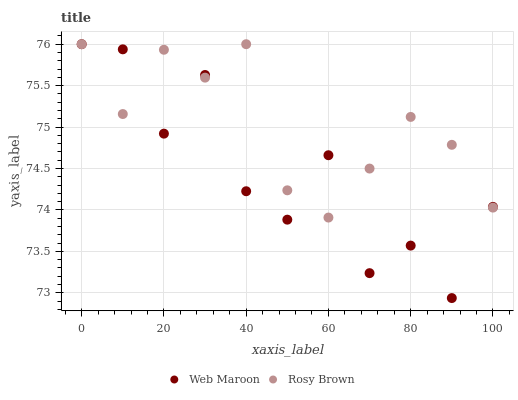Does Web Maroon have the minimum area under the curve?
Answer yes or no. Yes. Does Rosy Brown have the maximum area under the curve?
Answer yes or no. Yes. Does Web Maroon have the maximum area under the curve?
Answer yes or no. No. Is Rosy Brown the smoothest?
Answer yes or no. Yes. Is Web Maroon the roughest?
Answer yes or no. Yes. Is Web Maroon the smoothest?
Answer yes or no. No. Does Web Maroon have the lowest value?
Answer yes or no. Yes. Does Web Maroon have the highest value?
Answer yes or no. Yes. Does Web Maroon intersect Rosy Brown?
Answer yes or no. Yes. Is Web Maroon less than Rosy Brown?
Answer yes or no. No. Is Web Maroon greater than Rosy Brown?
Answer yes or no. No. 